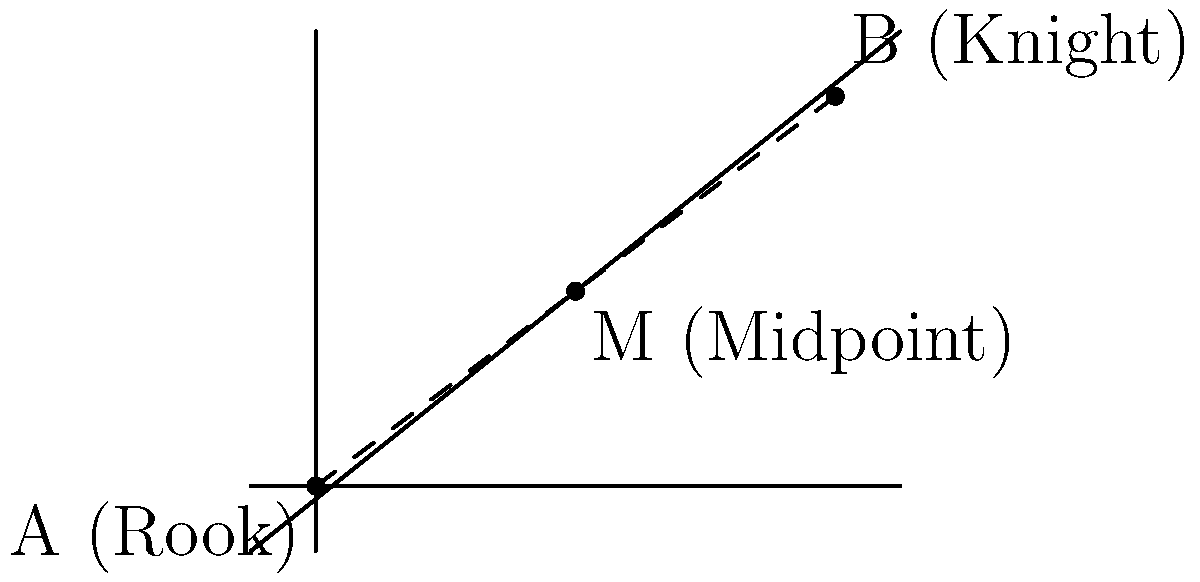In a chess game, a Rook is positioned at coordinates (0,0) and a Knight at (8,6) on the board. To optimize your positioning strategy, you need to find the midpoint between these two pieces. What are the coordinates of this midpoint? To find the midpoint between two points, we can use the midpoint formula:

$$ M = (\frac{x_1 + x_2}{2}, \frac{y_1 + y_2}{2}) $$

Where $(x_1, y_1)$ are the coordinates of the first point (Rook) and $(x_2, y_2)$ are the coordinates of the second point (Knight).

Step 1: Identify the coordinates
Rook (A): $(x_1, y_1) = (0, 0)$
Knight (B): $(x_2, y_2) = (8, 6)$

Step 2: Apply the midpoint formula
$$ x = \frac{x_1 + x_2}{2} = \frac{0 + 8}{2} = \frac{8}{2} = 4 $$
$$ y = \frac{y_1 + y_2}{2} = \frac{0 + 6}{2} = \frac{6}{2} = 3 $$

Step 3: Combine the results
The midpoint M has coordinates $(4, 3)$.

This midpoint represents the optimal position between the Rook and the Knight, which could be strategically important for planning your next move or understanding the balance of piece positioning on the board.
Answer: (4, 3) 